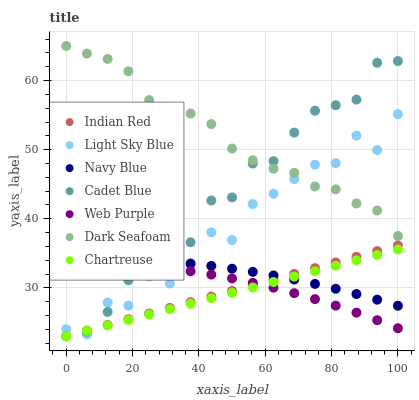Does Chartreuse have the minimum area under the curve?
Answer yes or no. Yes. Does Dark Seafoam have the maximum area under the curve?
Answer yes or no. Yes. Does Cadet Blue have the minimum area under the curve?
Answer yes or no. No. Does Cadet Blue have the maximum area under the curve?
Answer yes or no. No. Is Chartreuse the smoothest?
Answer yes or no. Yes. Is Light Sky Blue the roughest?
Answer yes or no. Yes. Is Cadet Blue the smoothest?
Answer yes or no. No. Is Cadet Blue the roughest?
Answer yes or no. No. Does Chartreuse have the lowest value?
Answer yes or no. Yes. Does Navy Blue have the lowest value?
Answer yes or no. No. Does Dark Seafoam have the highest value?
Answer yes or no. Yes. Does Cadet Blue have the highest value?
Answer yes or no. No. Is Web Purple less than Navy Blue?
Answer yes or no. Yes. Is Dark Seafoam greater than Web Purple?
Answer yes or no. Yes. Does Chartreuse intersect Cadet Blue?
Answer yes or no. Yes. Is Chartreuse less than Cadet Blue?
Answer yes or no. No. Is Chartreuse greater than Cadet Blue?
Answer yes or no. No. Does Web Purple intersect Navy Blue?
Answer yes or no. No. 